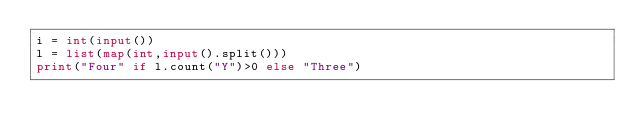Convert code to text. <code><loc_0><loc_0><loc_500><loc_500><_Python_>i = int(input())
l = list(map(int,input().split()))
print("Four" if l.count("Y")>0 else "Three")</code> 